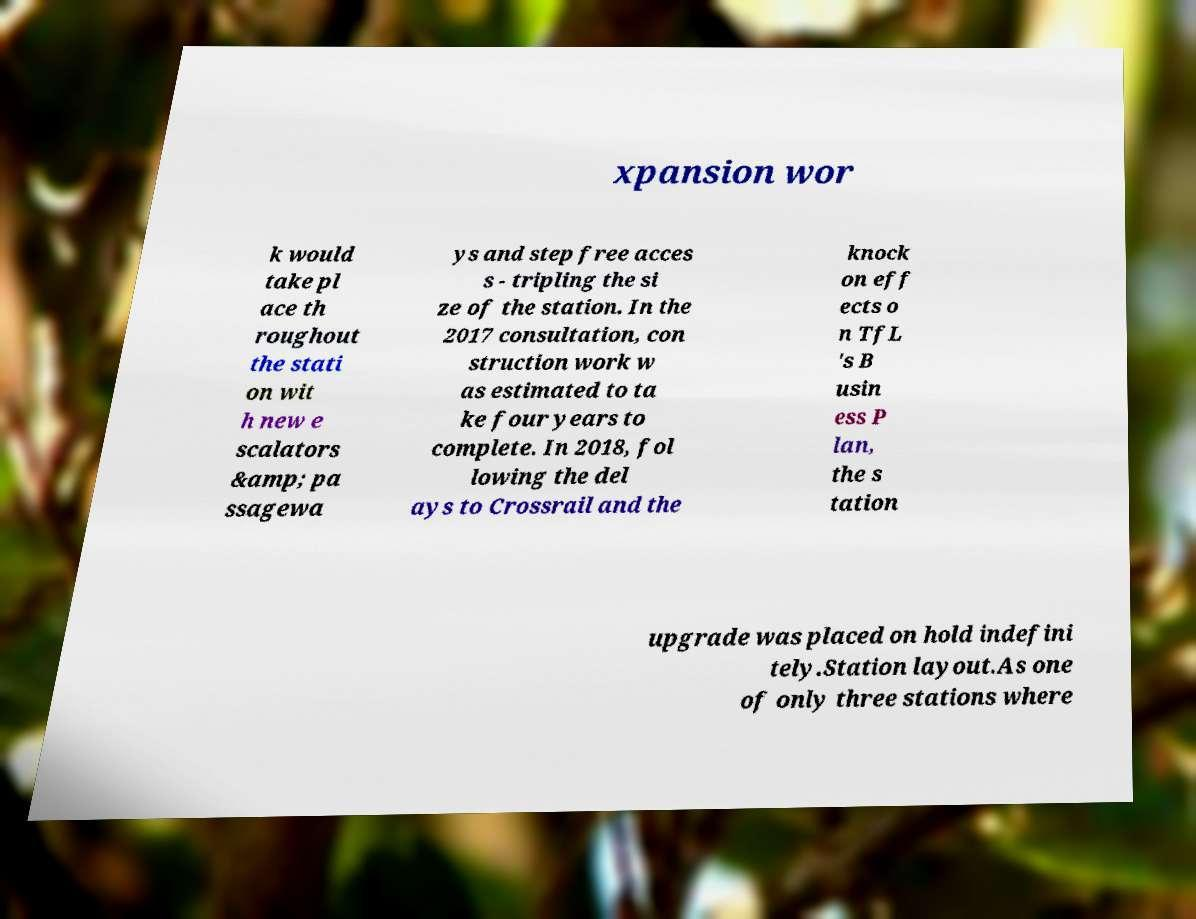Could you assist in decoding the text presented in this image and type it out clearly? xpansion wor k would take pl ace th roughout the stati on wit h new e scalators &amp; pa ssagewa ys and step free acces s - tripling the si ze of the station. In the 2017 consultation, con struction work w as estimated to ta ke four years to complete. In 2018, fol lowing the del ays to Crossrail and the knock on eff ects o n TfL 's B usin ess P lan, the s tation upgrade was placed on hold indefini tely.Station layout.As one of only three stations where 